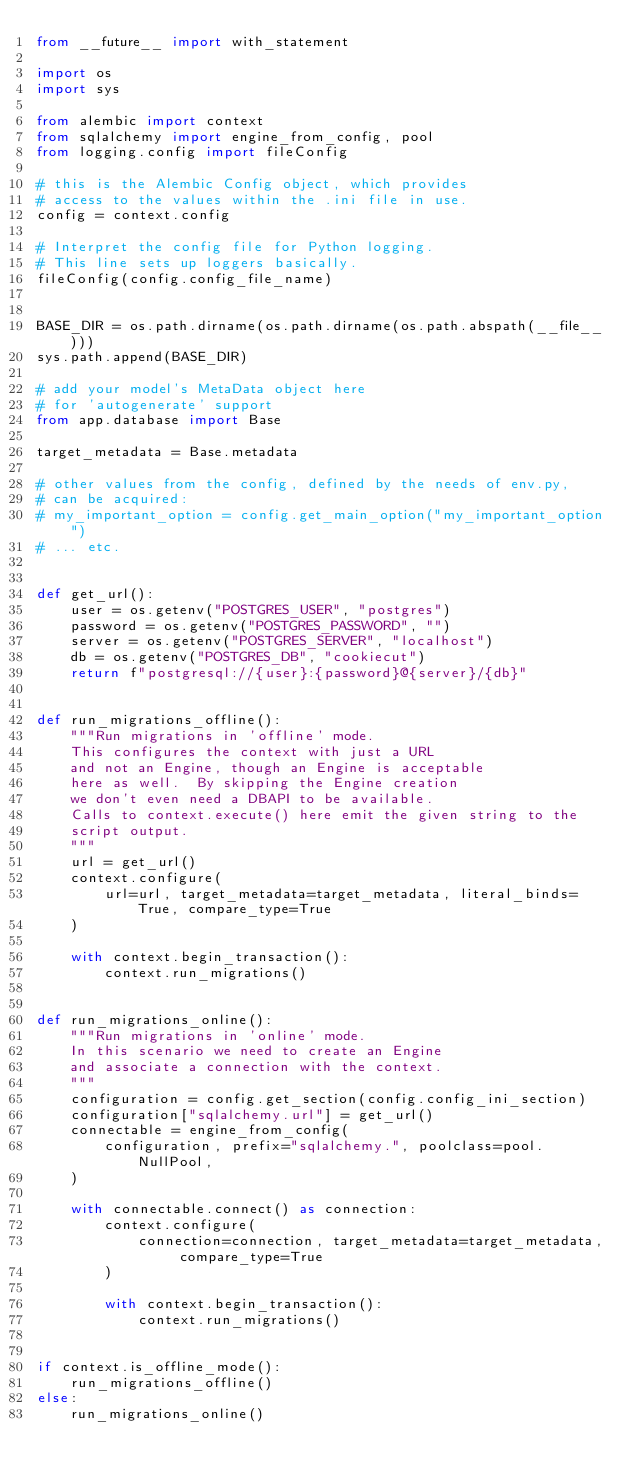<code> <loc_0><loc_0><loc_500><loc_500><_Python_>from __future__ import with_statement

import os
import sys

from alembic import context
from sqlalchemy import engine_from_config, pool
from logging.config import fileConfig

# this is the Alembic Config object, which provides
# access to the values within the .ini file in use.
config = context.config

# Interpret the config file for Python logging.
# This line sets up loggers basically.
fileConfig(config.config_file_name)


BASE_DIR = os.path.dirname(os.path.dirname(os.path.abspath(__file__)))
sys.path.append(BASE_DIR)

# add your model's MetaData object here
# for 'autogenerate' support
from app.database import Base

target_metadata = Base.metadata

# other values from the config, defined by the needs of env.py,
# can be acquired:
# my_important_option = config.get_main_option("my_important_option")
# ... etc.


def get_url():
    user = os.getenv("POSTGRES_USER", "postgres")
    password = os.getenv("POSTGRES_PASSWORD", "")
    server = os.getenv("POSTGRES_SERVER", "localhost")
    db = os.getenv("POSTGRES_DB", "cookiecut")
    return f"postgresql://{user}:{password}@{server}/{db}"


def run_migrations_offline():
    """Run migrations in 'offline' mode.
    This configures the context with just a URL
    and not an Engine, though an Engine is acceptable
    here as well.  By skipping the Engine creation
    we don't even need a DBAPI to be available.
    Calls to context.execute() here emit the given string to the
    script output.
    """
    url = get_url()
    context.configure(
        url=url, target_metadata=target_metadata, literal_binds=True, compare_type=True
    )

    with context.begin_transaction():
        context.run_migrations()


def run_migrations_online():
    """Run migrations in 'online' mode.
    In this scenario we need to create an Engine
    and associate a connection with the context.
    """
    configuration = config.get_section(config.config_ini_section)
    configuration["sqlalchemy.url"] = get_url()
    connectable = engine_from_config(
        configuration, prefix="sqlalchemy.", poolclass=pool.NullPool,
    )

    with connectable.connect() as connection:
        context.configure(
            connection=connection, target_metadata=target_metadata, compare_type=True
        )

        with context.begin_transaction():
            context.run_migrations()


if context.is_offline_mode():
    run_migrations_offline()
else:
    run_migrations_online()
</code> 